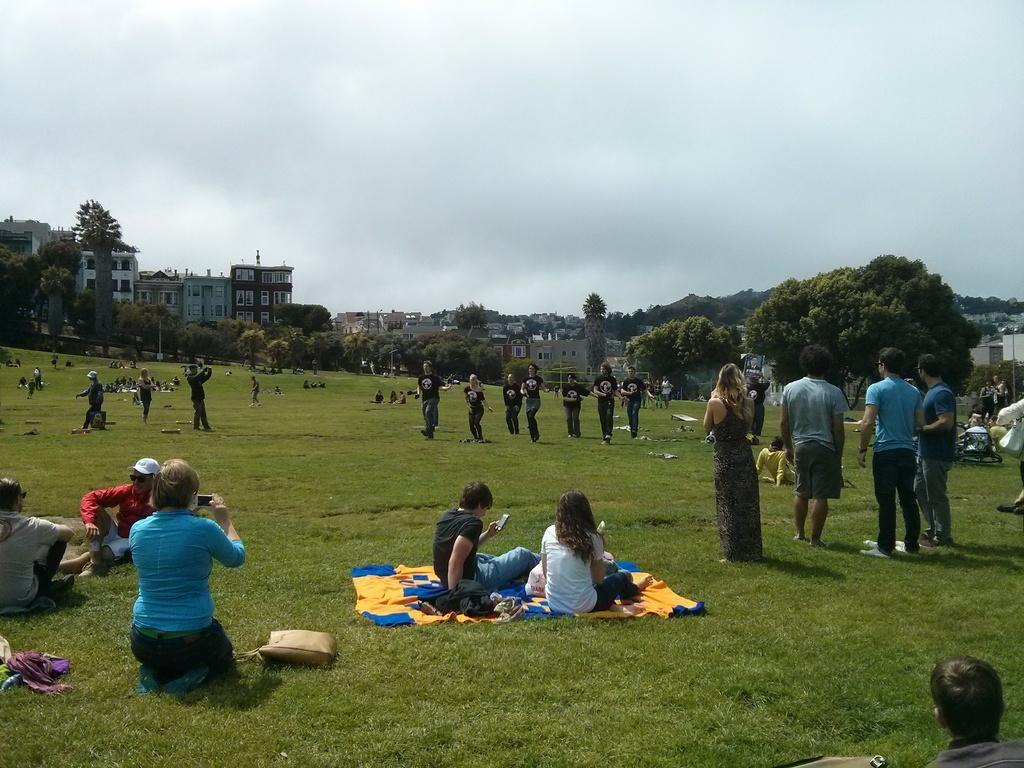Can you describe this image briefly? In this image there are persons sitting, standing and dancing. In the front on the ground there is grass and there is a purse. In the background there are trees, buildings, and the sky is cloudy. 